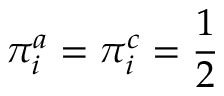Convert formula to latex. <formula><loc_0><loc_0><loc_500><loc_500>\pi _ { i } ^ { a } = \pi _ { i } ^ { c } = \frac { 1 } { 2 }</formula> 